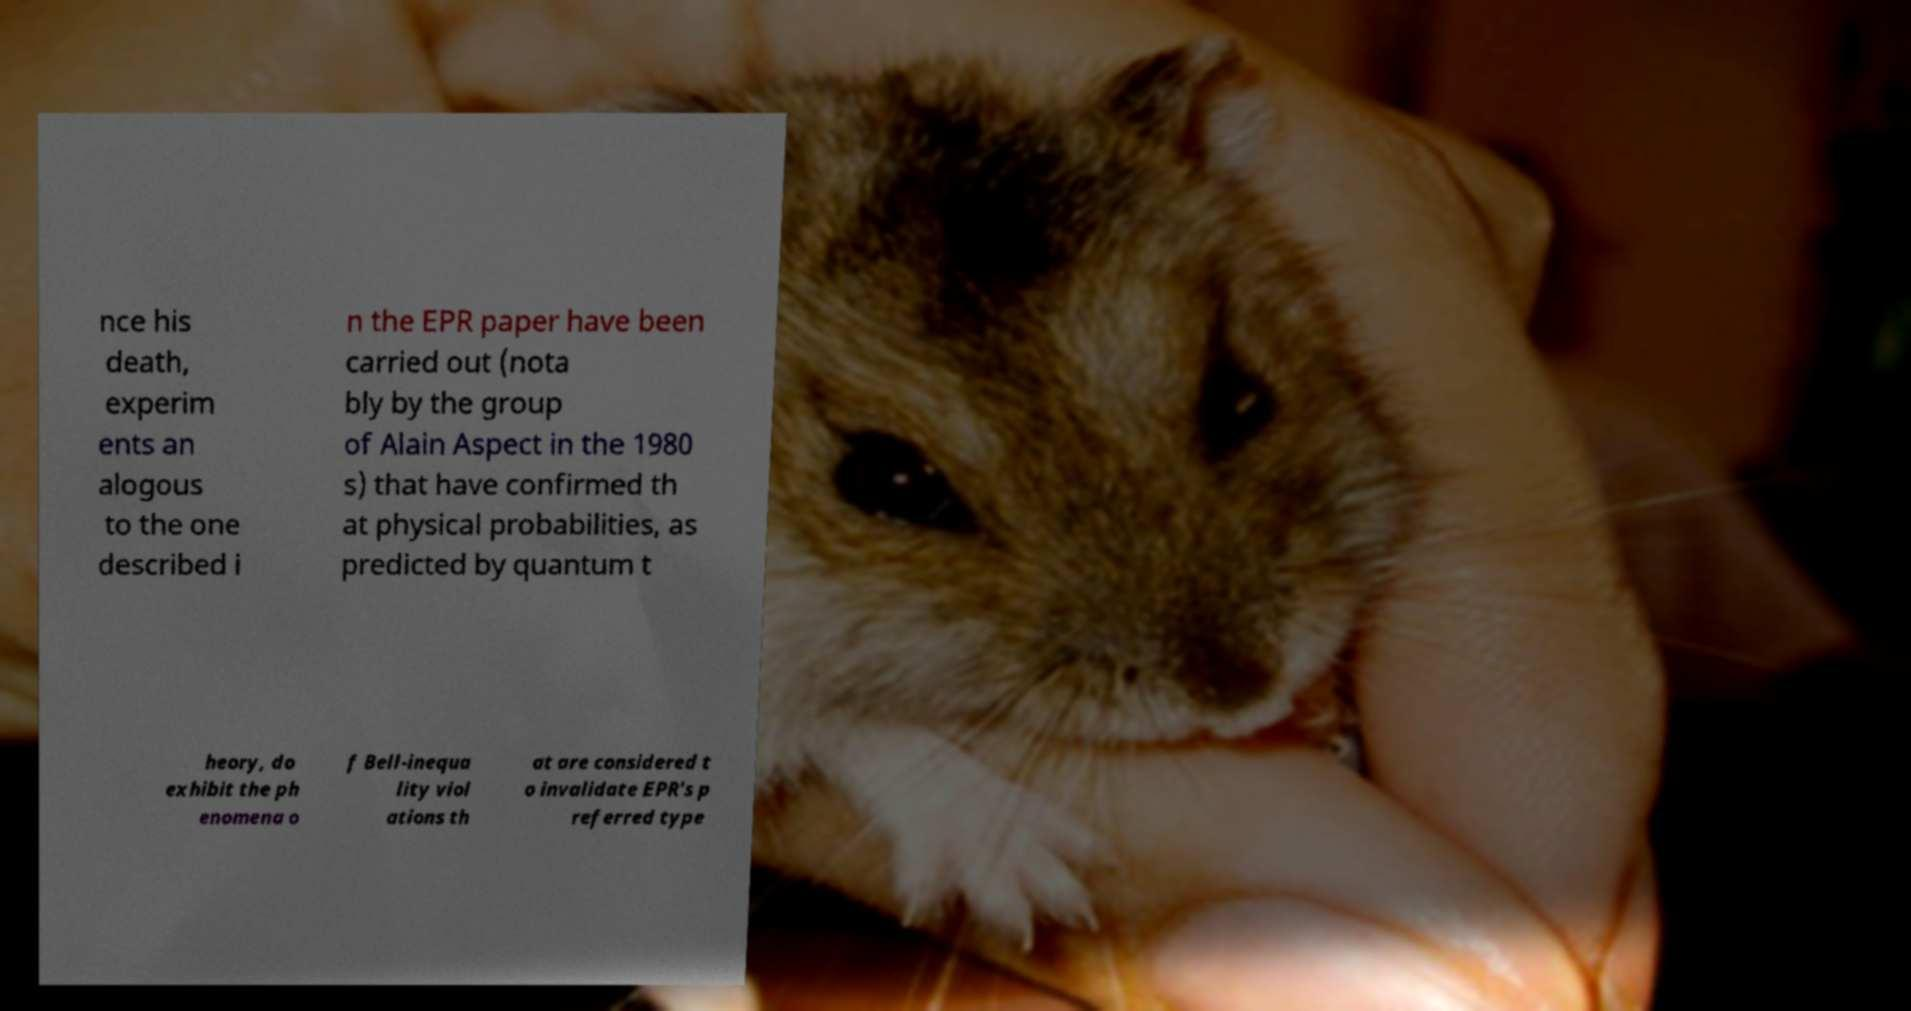For documentation purposes, I need the text within this image transcribed. Could you provide that? nce his death, experim ents an alogous to the one described i n the EPR paper have been carried out (nota bly by the group of Alain Aspect in the 1980 s) that have confirmed th at physical probabilities, as predicted by quantum t heory, do exhibit the ph enomena o f Bell-inequa lity viol ations th at are considered t o invalidate EPR's p referred type 